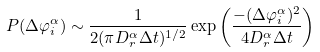Convert formula to latex. <formula><loc_0><loc_0><loc_500><loc_500>P ( \Delta \varphi _ { i } ^ { \alpha } ) \sim \frac { 1 } { 2 ( \pi D _ { r } ^ { \alpha } \Delta t ) ^ { 1 / 2 } } \exp { \left ( \frac { - ( \Delta \varphi _ { i } ^ { \alpha } ) ^ { 2 } } { 4 D _ { r } ^ { \alpha } \Delta t } \right ) }</formula> 